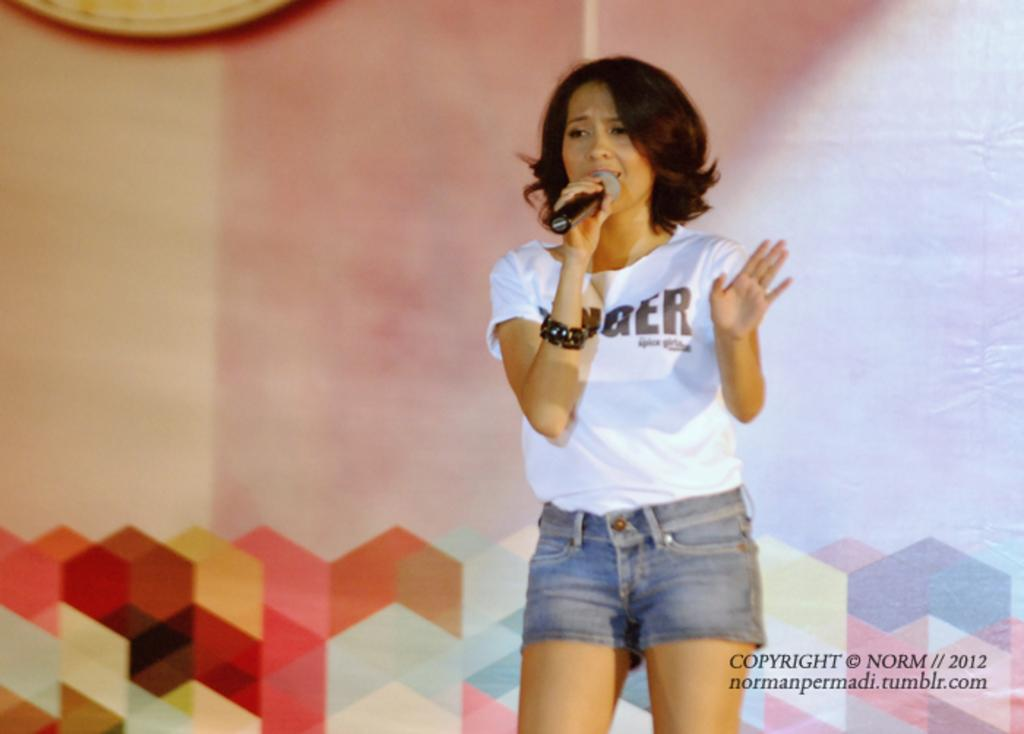Who is the main subject in the image? There is a woman in the image. What is the woman doing in the image? The woman is singing a song. What object is the woman holding in her hand? The woman is holding a microphone in her hand. What type of coal can be seen in the image? There is no coal present in the image. What is the angle of the library in the image? There is no library present in the image. 